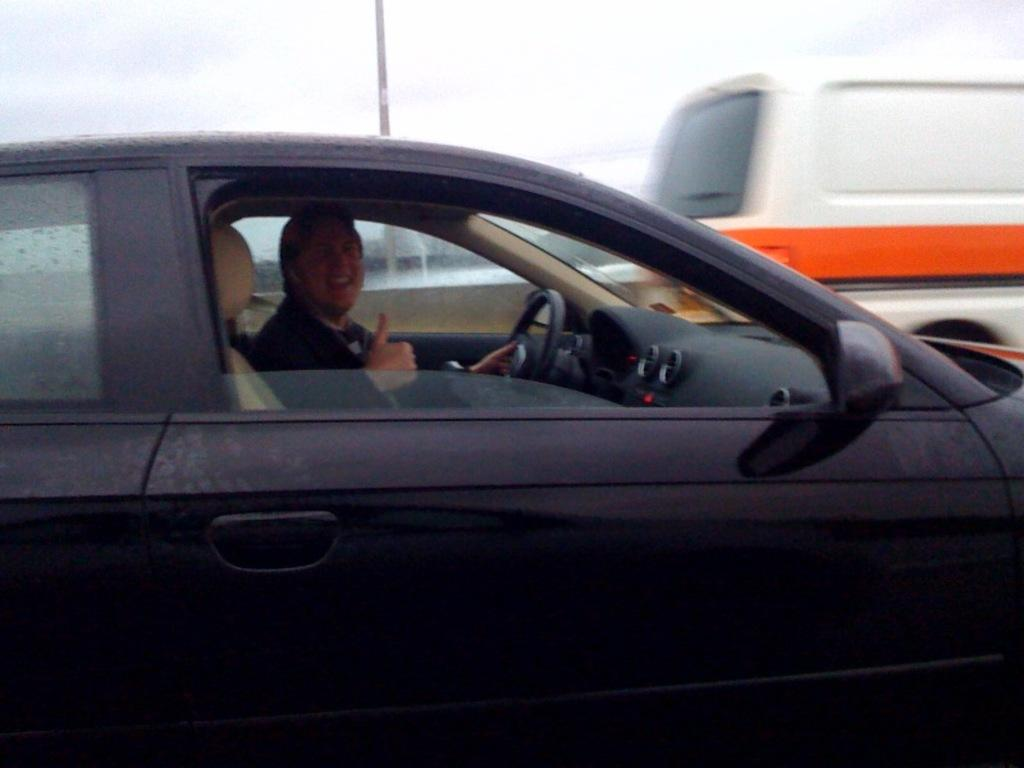What is the main subject of the image? The main subject of the image is a car on the road. Who is inside the car? A person is sitting in the car. What is the person doing in the car? The person is driving the car. Can you describe the situation on the road? There is a vehicle in front of the car. What type of farm can be seen in the background of the image? There is no farm visible in the image; it features a car on the road with a vehicle in front of it. How many corks are present in the image? There are no corks present in the image. 